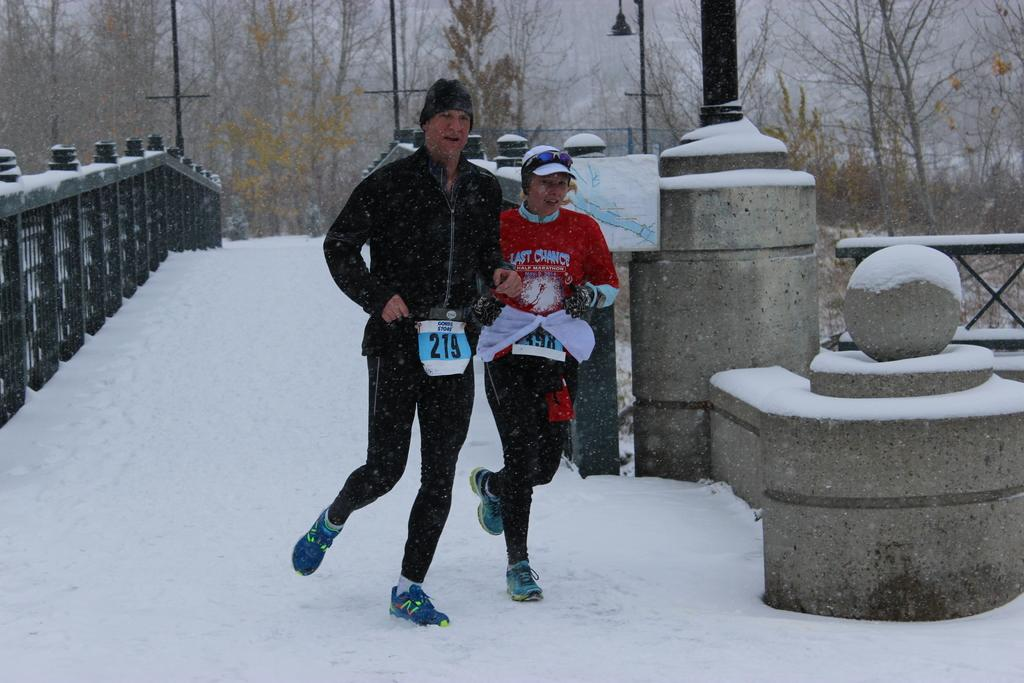Provide a one-sentence caption for the provided image. A man and a woman are running down a snowy bridge with the man having the number 219 hanging off him. 